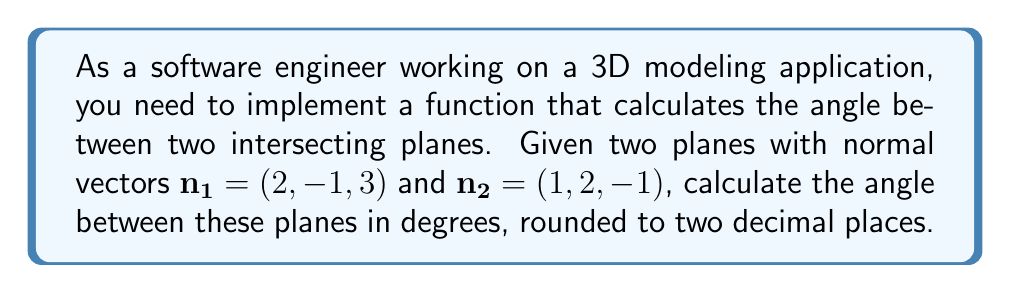Could you help me with this problem? To solve this problem, we'll follow these steps:

1) The angle between two planes is the same as the angle between their normal vectors. We can use the dot product formula to find this angle:

   $$\cos \theta = \frac{\mathbf{n_1} \cdot \mathbf{n_2}}{|\mathbf{n_1}| |\mathbf{n_2}|}$$

2) Let's calculate the dot product $\mathbf{n_1} \cdot \mathbf{n_2}$:
   
   $$\mathbf{n_1} \cdot \mathbf{n_2} = (2)(1) + (-1)(2) + (3)(-1) = 2 - 2 - 3 = -3$$

3) Now, let's calculate the magnitudes of the vectors:

   $$|\mathbf{n_1}| = \sqrt{2^2 + (-1)^2 + 3^2} = \sqrt{4 + 1 + 9} = \sqrt{14}$$
   $$|\mathbf{n_2}| = \sqrt{1^2 + 2^2 + (-1)^2} = \sqrt{1 + 4 + 1} = \sqrt{6}$$

4) Substituting these values into our formula:

   $$\cos \theta = \frac{-3}{\sqrt{14} \sqrt{6}}$$

5) To find $\theta$, we need to take the inverse cosine (arccos) of both sides:

   $$\theta = \arccos(\frac{-3}{\sqrt{14} \sqrt{6}})$$

6) Calculate this value and convert to degrees:

   $$\theta = \arccos(\frac{-3}{\sqrt{14} \sqrt{6}}) \cdot \frac{180}{\pi} \approx 106.60^\circ$$

7) Rounding to two decimal places gives us 106.60°.
Answer: 106.60° 